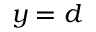<formula> <loc_0><loc_0><loc_500><loc_500>y = d</formula> 